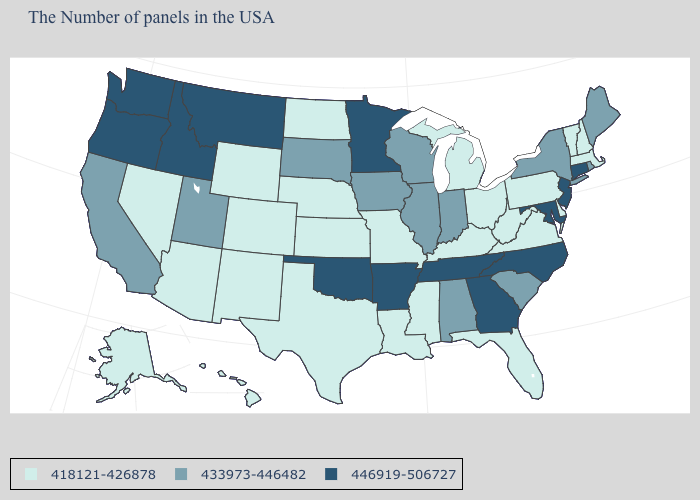Does New Jersey have the highest value in the Northeast?
Keep it brief. Yes. Which states have the lowest value in the West?
Quick response, please. Wyoming, Colorado, New Mexico, Arizona, Nevada, Alaska, Hawaii. Is the legend a continuous bar?
Quick response, please. No. Name the states that have a value in the range 433973-446482?
Keep it brief. Maine, Rhode Island, New York, South Carolina, Indiana, Alabama, Wisconsin, Illinois, Iowa, South Dakota, Utah, California. Among the states that border Illinois , which have the highest value?
Keep it brief. Indiana, Wisconsin, Iowa. What is the value of Kansas?
Keep it brief. 418121-426878. Name the states that have a value in the range 418121-426878?
Write a very short answer. Massachusetts, New Hampshire, Vermont, Delaware, Pennsylvania, Virginia, West Virginia, Ohio, Florida, Michigan, Kentucky, Mississippi, Louisiana, Missouri, Kansas, Nebraska, Texas, North Dakota, Wyoming, Colorado, New Mexico, Arizona, Nevada, Alaska, Hawaii. Among the states that border Montana , does Idaho have the highest value?
Give a very brief answer. Yes. Does Colorado have a higher value than Louisiana?
Answer briefly. No. What is the value of Wyoming?
Quick response, please. 418121-426878. Does Arkansas have the lowest value in the USA?
Keep it brief. No. What is the lowest value in the South?
Quick response, please. 418121-426878. Name the states that have a value in the range 446919-506727?
Give a very brief answer. Connecticut, New Jersey, Maryland, North Carolina, Georgia, Tennessee, Arkansas, Minnesota, Oklahoma, Montana, Idaho, Washington, Oregon. Among the states that border Nebraska , does Iowa have the highest value?
Give a very brief answer. Yes. Name the states that have a value in the range 446919-506727?
Answer briefly. Connecticut, New Jersey, Maryland, North Carolina, Georgia, Tennessee, Arkansas, Minnesota, Oklahoma, Montana, Idaho, Washington, Oregon. 